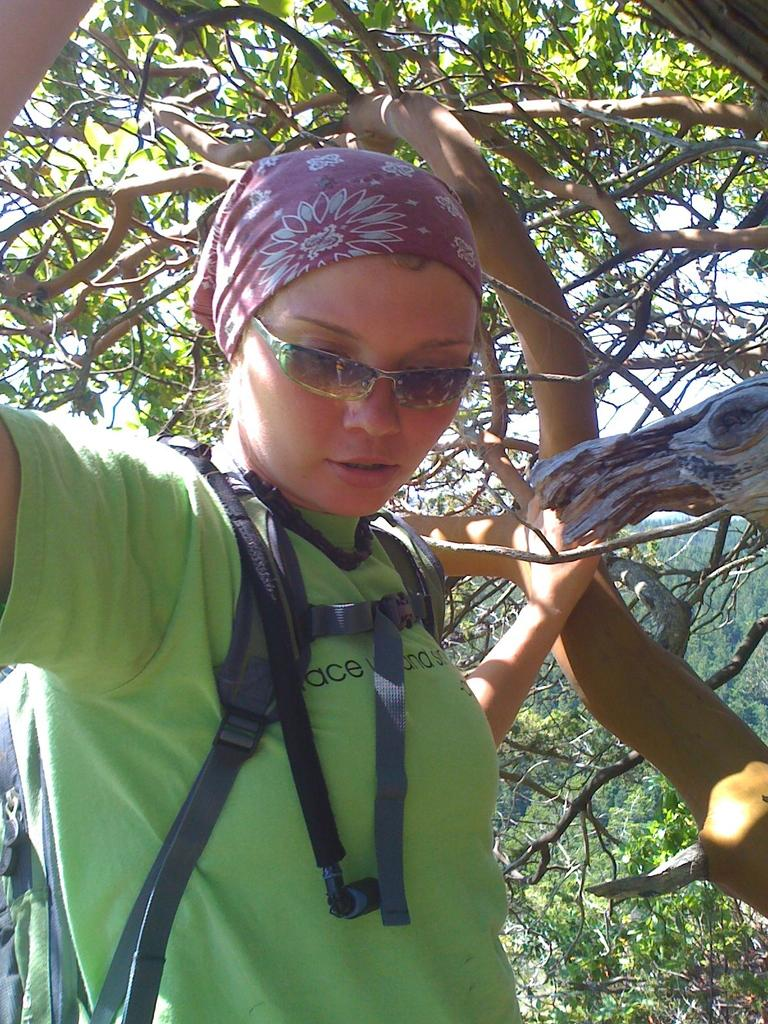What is the main subject of the image? The main subject of the image is a person standing in the center of the image. Can you describe the background of the image? There is a tree in the background of the image. What type of thrill can be seen on the coast in the image? There is no coast or thrill present in the image; it features a person standing in the center and a tree in the background. What type of instrument is being played by the person in the image? There is no instrument present in the image, and the person is not shown playing any instrument. 